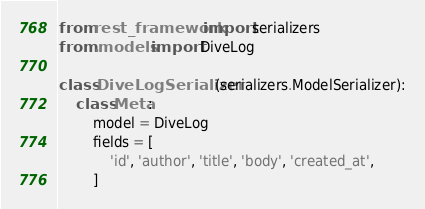Convert code to text. <code><loc_0><loc_0><loc_500><loc_500><_Python_>from rest_framework import serializers
from .models import DiveLog

class DiveLogSerializer(serializers.ModelSerializer):
    class Meta:
        model = DiveLog
        fields = [
            'id', 'author', 'title', 'body', 'created_at',
        ]</code> 